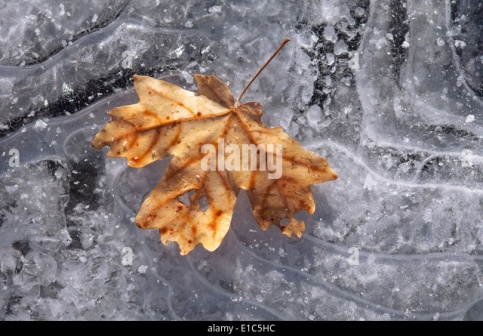Imagine you found a journal under this leaf. What could it contain? The journal hidden beneath the leaf is ancient, its pages yellowed with age, and the cover slightly worn. Upon opening it, you discover beautiful sketches of various leaves and detailed observations of how they change with the seasons. The entries describe the author's meticulous observations of nature, capturing the subtle interplay of sunlight on frost, the way leaves curl as they freeze, and the different types of ice crystals that form on the surface. There's a sense of wonder and reverence in the writings, a deep appreciation for the beauty and intricacy of the natural world. The final entry is poignant, reflecting on the cycle of life and the passage of time, written during the author's final days. What other fascinating things could be discovered in this icy scene? Exploring this icy scene further, one might uncover tiny air bubbles trapped just beneath the surface. Each bubble, a small world unto itself, might contain microscopic life, frozen in time. Additionally, the varying patterns in the ice could be caused by impurities or small debris trapped as the water froze. These patterns, when studied closely, reveal the history of the freezing process, giving clues about the temperatures and conditions during the formation of ice. In one spot, you might find a perfectly preserved insect or a seed, providing insight into the local ecosystem and how it adapts to harsh winters. The depth of the ice here could also be measured to determine the thickness, revealing more about the seasonal climate changes in the area. Picture the leaf in a fairy tale setting. What role does it play in the story? In a mystical fairy tale world, the leaf in the image is no ordinary leaf—it is the enchanted key to an ancient forest kingdom. Legend has it that this maple leaf belongs to the Great Tree, a sentient being that guards the secrets of the forest. The leaf, imbued with magical powers, only falls when the forest is in dire need. A young, curious adventurer finds the leaf and is chosen to embark on a quest to restore balance to the kingdom. Guided by forest creatures and the wisdom of the Great Tree, the adventurer must navigate treacherous terrain, solve ancient riddles, and confront dark forces intent on seizing the forest's magic. With the leaf's help, the adventurer unlocks hidden pathways and discovers the heart of the forest, where they must make a selfless choice to save the kingdom and return harmony to the enchanted land. 